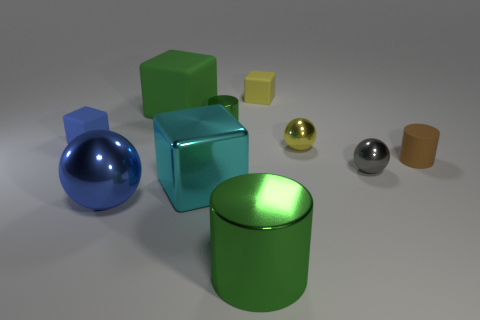Subtract 1 spheres. How many spheres are left? 2 Subtract all purple cubes. Subtract all red spheres. How many cubes are left? 4 Subtract all cylinders. How many objects are left? 7 Subtract 0 purple spheres. How many objects are left? 10 Subtract all small brown rubber cylinders. Subtract all large blocks. How many objects are left? 7 Add 8 big cyan metal cubes. How many big cyan metal cubes are left? 9 Add 10 red matte spheres. How many red matte spheres exist? 10 